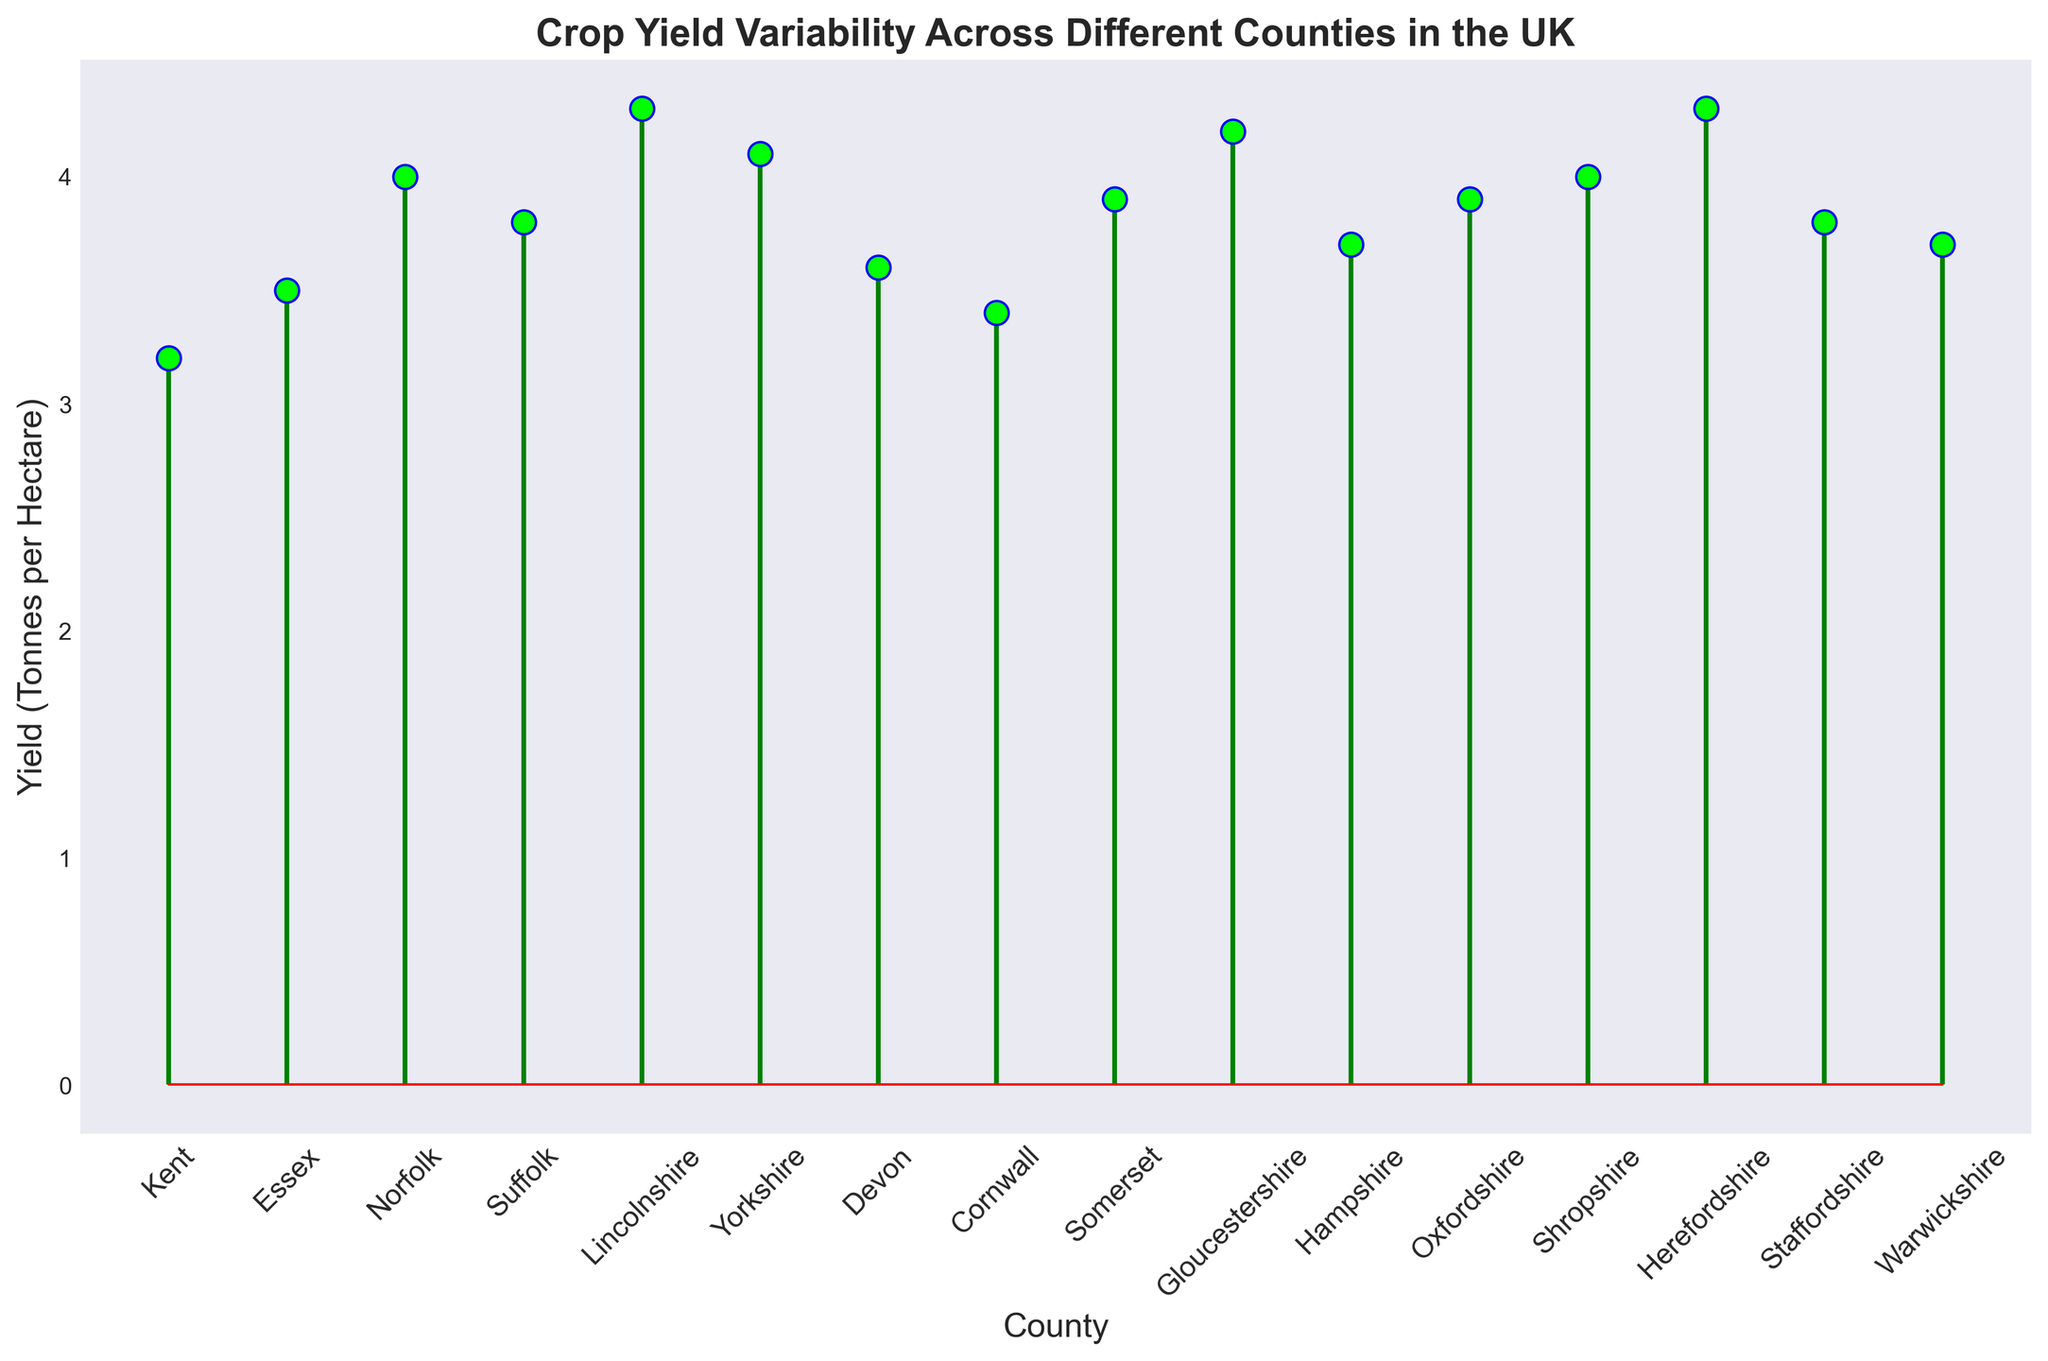Which county has the highest crop yield? Look for the county with the highest point on the stem plot. Herefordshire has the highest crop yield at 4.3 tonnes per hectare.
Answer: Herefordshire Which county has a lower crop yield, Essex or Cornwall? Compare the heights of the points for Essex and Cornwall. Essex has 3.5 tonnes per hectare, whereas Cornwall has 3.4 tonnes per hectare.
Answer: Cornwall What is the average crop yield across all counties? Add up all the yields and divide by the number of counties: (3.2 + 3.5 + 4.0 + 3.8 + 4.3 + 4.1 + 3.6 + 3.4 + 3.9 + 4.2 + 3.7 + 3.9 + 4.0 + 4.3 + 3.8 + 3.7) / 16.
Answer: 3.875 How many counties have a crop yield greater than 4.0 tonnes per hectare? Count the number of points that are above 4.0 tonnes per hectare. Lincolnshire (4.3), Yorkshire (4.1), Gloucestershire (4.2), Shropshire (4.0, equal to 4.0 or above), Herefordshire (4.3). This totals 5 counties.
Answer: 5 What is the difference in crop yield between Norfolk and Staffordshire? Subtract the yield of Staffordshire (3.8) from Norfolk (4.0): 4.0 - 3.8.
Answer: 0.2 Which counties have the same crop yield and what is that value? Identify the counties with the same point height on the plot. Norfolk and Shropshire both have 4.0 tonnes per hectare, and Oxfordshire and Somerset both have 3.9 tonnes per hectare.
Answer: Norfolk, Shropshire and Oxfordshire, Somerset Which county has the lowest crop yield? Look for the county with the lowest point on the stem plot. Kent has the lowest crop yield at 3.2 tonnes per hectare.
Answer: Kent How does the crop yield of Lincolnshire compare to that of Gloucestershire? Compare the heights of their points on the stem plot. Lincolnshire has a yield of 4.3 tonnes per hectare, while Gloucestershire has 4.2 tonnes per hectare. Lincolnshire's yield is slightly higher.
Answer: Lincolnshire What's the median crop yield of all the counties? List all yields in ascending order and find the median (the middle value in the list). Ordered yields: 3.2, 3.4, 3.5, 3.6, 3.7, 3.7, 3.8, 3.8, 3.9, 3.9, 4.0, 4.0, 4.1, 4.2, 4.3, 4.3. The middle values are 3.85 and 3.9, so the median is 3.875.
Answer: 3.875 Which counties have crop yields that are within 0.1 tonnes per hectare of each other? Identify and compare heights of points that are close in value. Devon (3.6) and Hampshire (3.7), Lincolnshire (4.3) and Herefordshire (4.3), Warwickshire (3.7) and Hampshire (3.7).
Answer: Devon, Hampshire; Lincolnshire, Herefordshire; Warwickshire, Hampshire 